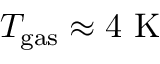Convert formula to latex. <formula><loc_0><loc_0><loc_500><loc_500>T _ { g a s } \approx 4 K</formula> 